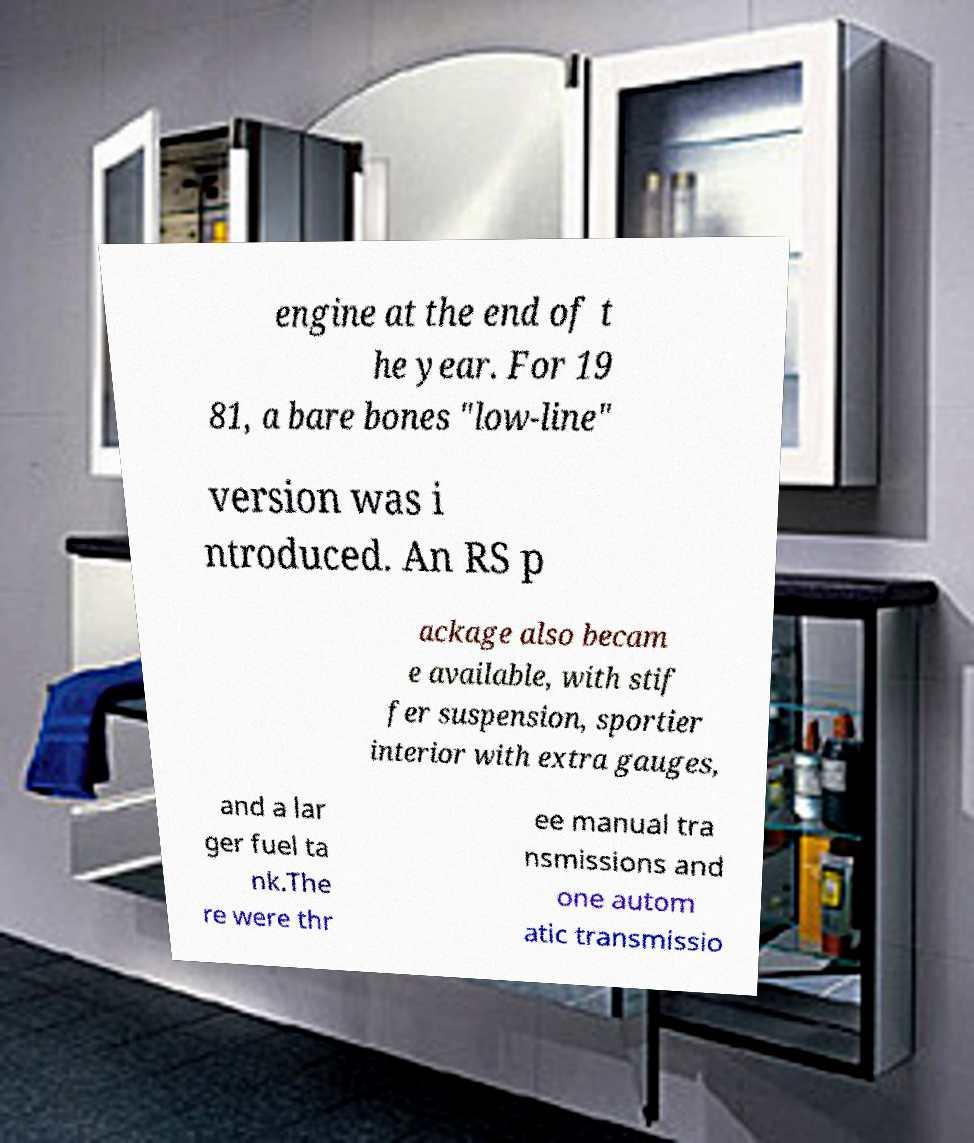I need the written content from this picture converted into text. Can you do that? engine at the end of t he year. For 19 81, a bare bones "low-line" version was i ntroduced. An RS p ackage also becam e available, with stif fer suspension, sportier interior with extra gauges, and a lar ger fuel ta nk.The re were thr ee manual tra nsmissions and one autom atic transmissio 